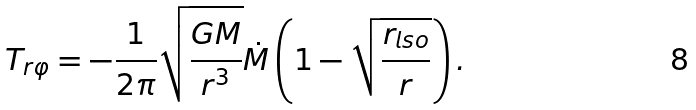<formula> <loc_0><loc_0><loc_500><loc_500>T _ { r \varphi } = - \frac { 1 } { 2 \pi } \sqrt { \frac { G M } { r ^ { 3 } } } \dot { M } \left ( 1 - \sqrt { \frac { r _ { l s o } } { r } } \right ) .</formula> 